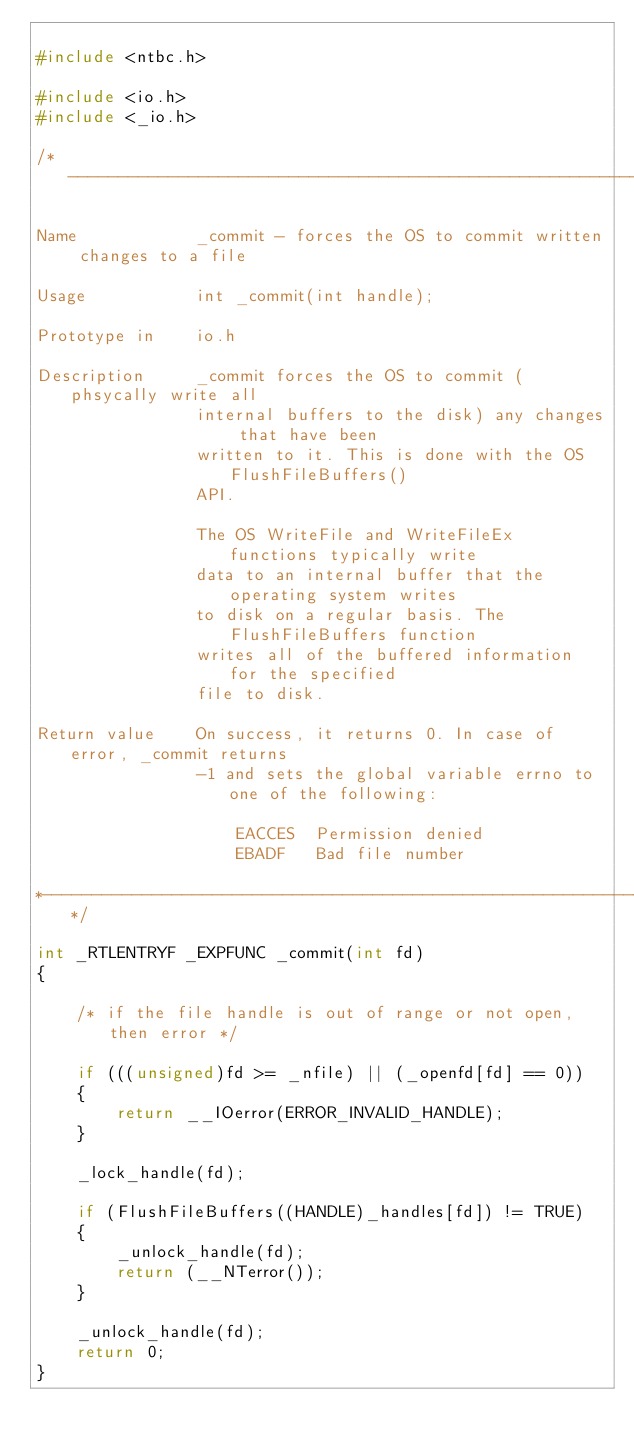<code> <loc_0><loc_0><loc_500><loc_500><_C_>
#include <ntbc.h>

#include <io.h>
#include <_io.h>

/*-----------------------------------------------------------------------*

Name            _commit - forces the OS to commit written changes to a file

Usage           int _commit(int handle);

Prototype in    io.h

Description     _commit forces the OS to commit (phsycally write all
                internal buffers to the disk) any changes that have been
                written to it. This is done with the OS FlushFileBuffers()
                API.

                The OS WriteFile and WriteFileEx functions typically write
                data to an internal buffer that the operating system writes
                to disk on a regular basis. The FlushFileBuffers function
                writes all of the buffered information for the specified
                file to disk.

Return value    On success, it returns 0. In case of error, _commit returns
                -1 and sets the global variable errno to one of the following:

                    EACCES  Permission denied
                    EBADF   Bad file number

*------------------------------------------------------------------------*/

int _RTLENTRYF _EXPFUNC _commit(int fd)
{

    /* if the file handle is out of range or not open, then error */

    if (((unsigned)fd >= _nfile) || (_openfd[fd] == 0))
    {
        return __IOerror(ERROR_INVALID_HANDLE);
    }

    _lock_handle(fd);

    if (FlushFileBuffers((HANDLE)_handles[fd]) != TRUE)
    {
        _unlock_handle(fd);
        return (__NTerror());
    }

    _unlock_handle(fd);
    return 0;
}
</code> 